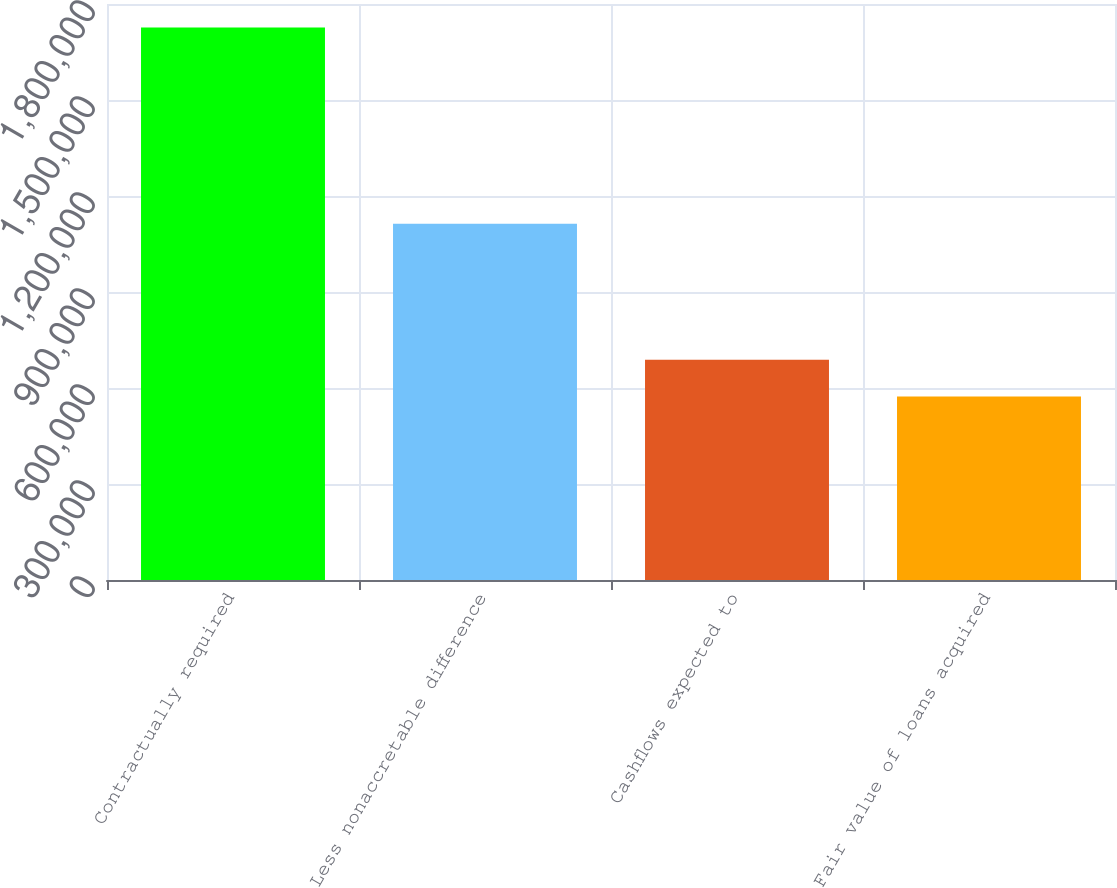Convert chart to OTSL. <chart><loc_0><loc_0><loc_500><loc_500><bar_chart><fcel>Contractually required<fcel>Less nonaccretable difference<fcel>Cashflows expected to<fcel>Fair value of loans acquired<nl><fcel>1.72643e+06<fcel>1.1135e+06<fcel>688476<fcel>573148<nl></chart> 